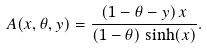Convert formula to latex. <formula><loc_0><loc_0><loc_500><loc_500>A ( x , \theta , y ) = \frac { ( 1 - \theta - y ) \, x } { ( 1 - \theta ) \, \sinh ( x ) } .</formula> 